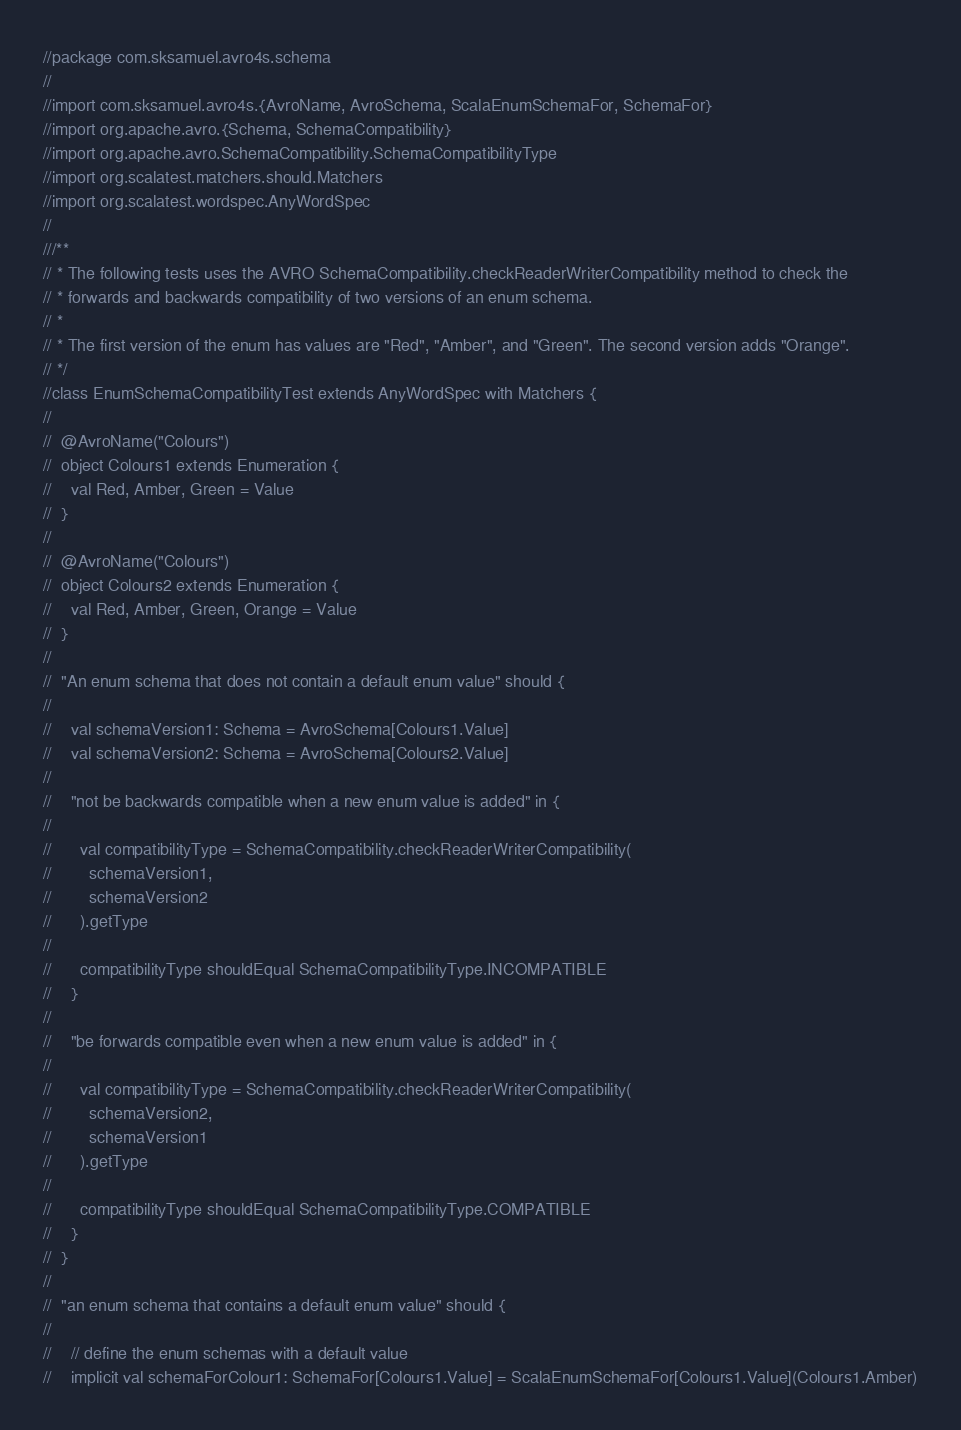Convert code to text. <code><loc_0><loc_0><loc_500><loc_500><_Scala_>//package com.sksamuel.avro4s.schema
//
//import com.sksamuel.avro4s.{AvroName, AvroSchema, ScalaEnumSchemaFor, SchemaFor}
//import org.apache.avro.{Schema, SchemaCompatibility}
//import org.apache.avro.SchemaCompatibility.SchemaCompatibilityType
//import org.scalatest.matchers.should.Matchers
//import org.scalatest.wordspec.AnyWordSpec
//
///**
// * The following tests uses the AVRO SchemaCompatibility.checkReaderWriterCompatibility method to check the
// * forwards and backwards compatibility of two versions of an enum schema.
// *
// * The first version of the enum has values are "Red", "Amber", and "Green". The second version adds "Orange".
// */
//class EnumSchemaCompatibilityTest extends AnyWordSpec with Matchers {
//
//  @AvroName("Colours")
//  object Colours1 extends Enumeration {
//    val Red, Amber, Green = Value
//  }
//
//  @AvroName("Colours")
//  object Colours2 extends Enumeration {
//    val Red, Amber, Green, Orange = Value
//  }
//
//  "An enum schema that does not contain a default enum value" should {
//
//    val schemaVersion1: Schema = AvroSchema[Colours1.Value]
//    val schemaVersion2: Schema = AvroSchema[Colours2.Value]
//
//    "not be backwards compatible when a new enum value is added" in {
//
//      val compatibilityType = SchemaCompatibility.checkReaderWriterCompatibility(
//        schemaVersion1,
//        schemaVersion2
//      ).getType
//
//      compatibilityType shouldEqual SchemaCompatibilityType.INCOMPATIBLE
//    }
//
//    "be forwards compatible even when a new enum value is added" in {
//
//      val compatibilityType = SchemaCompatibility.checkReaderWriterCompatibility(
//        schemaVersion2,
//        schemaVersion1
//      ).getType
//
//      compatibilityType shouldEqual SchemaCompatibilityType.COMPATIBLE
//    }
//  }
//
//  "an enum schema that contains a default enum value" should {
//
//    // define the enum schemas with a default value
//    implicit val schemaForColour1: SchemaFor[Colours1.Value] = ScalaEnumSchemaFor[Colours1.Value](Colours1.Amber)</code> 